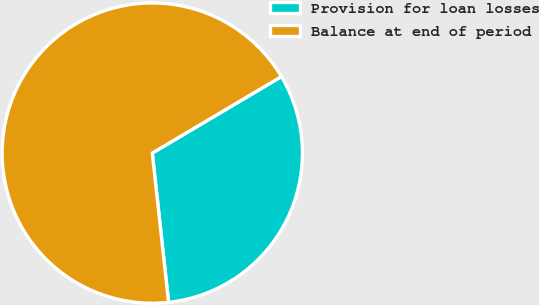Convert chart. <chart><loc_0><loc_0><loc_500><loc_500><pie_chart><fcel>Provision for loan losses<fcel>Balance at end of period<nl><fcel>31.78%<fcel>68.22%<nl></chart> 